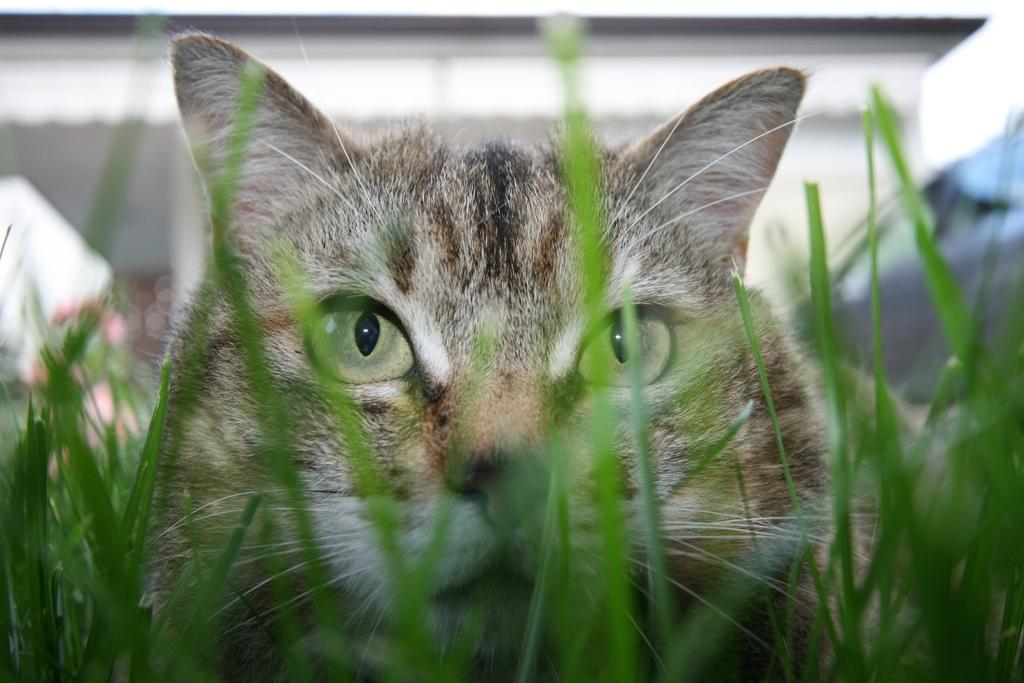What color is the grass in the image? The grass in the image is green. What animal can be seen in the image? There is a cat in the image. What colors does the cat have? The cat has cream, brown, and black colors. Where is the cat located in the image? The cat is in the grass. How would you describe the background of the image? The background of the image is blurry. Can you tell me the reason the cat is standing next to the stream in the image? There is no stream present in the image, and therefore no reason can be given for the cat's position. 